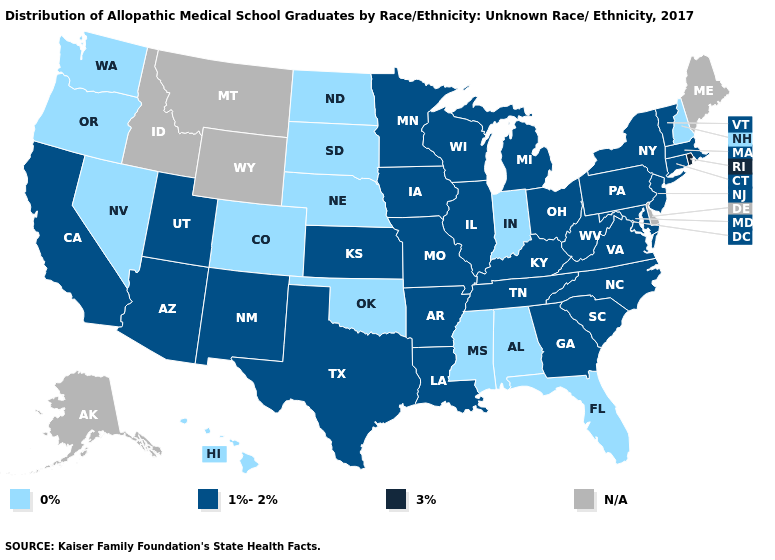Name the states that have a value in the range 3%?
Keep it brief. Rhode Island. Is the legend a continuous bar?
Concise answer only. No. Name the states that have a value in the range 1%-2%?
Give a very brief answer. Arizona, Arkansas, California, Connecticut, Georgia, Illinois, Iowa, Kansas, Kentucky, Louisiana, Maryland, Massachusetts, Michigan, Minnesota, Missouri, New Jersey, New Mexico, New York, North Carolina, Ohio, Pennsylvania, South Carolina, Tennessee, Texas, Utah, Vermont, Virginia, West Virginia, Wisconsin. Does Alabama have the lowest value in the South?
Concise answer only. Yes. What is the lowest value in states that border New Jersey?
Answer briefly. 1%-2%. What is the value of Kentucky?
Be succinct. 1%-2%. What is the value of Missouri?
Write a very short answer. 1%-2%. Which states have the highest value in the USA?
Keep it brief. Rhode Island. What is the value of Nevada?
Give a very brief answer. 0%. What is the value of South Dakota?
Be succinct. 0%. Does Rhode Island have the highest value in the USA?
Be succinct. Yes. Which states have the lowest value in the Northeast?
Quick response, please. New Hampshire. What is the lowest value in the MidWest?
Give a very brief answer. 0%. How many symbols are there in the legend?
Answer briefly. 4. What is the lowest value in the USA?
Answer briefly. 0%. 